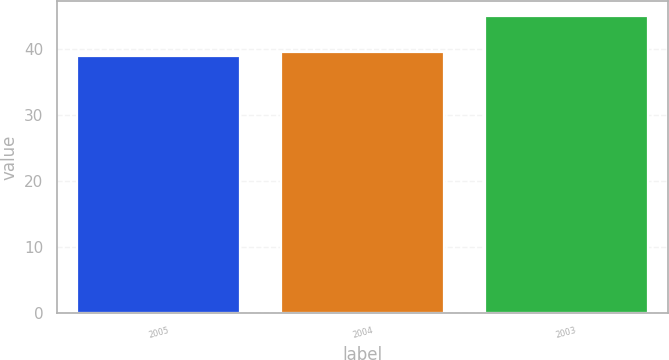Convert chart. <chart><loc_0><loc_0><loc_500><loc_500><bar_chart><fcel>2005<fcel>2004<fcel>2003<nl><fcel>39<fcel>39.6<fcel>45<nl></chart> 